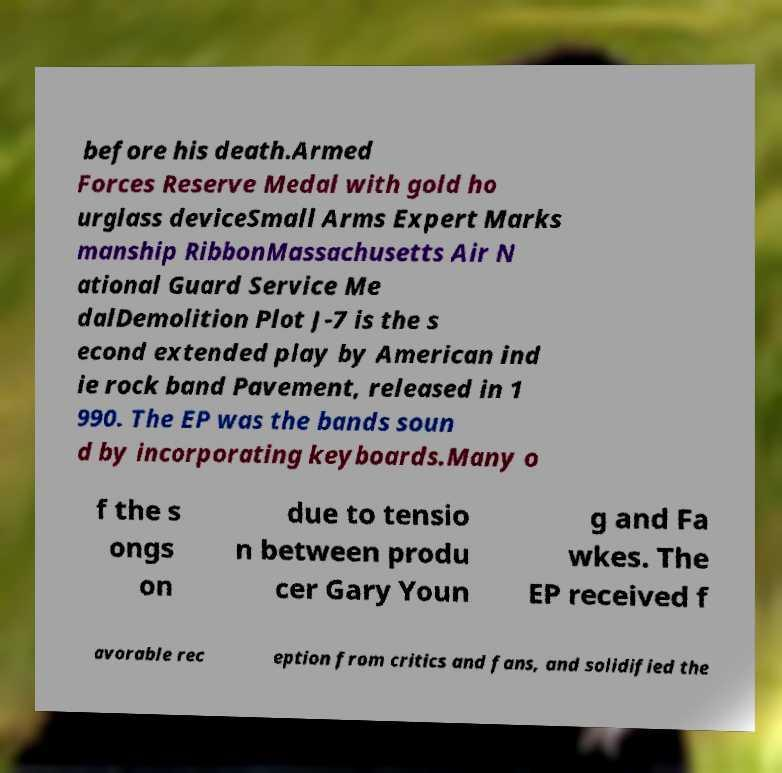I need the written content from this picture converted into text. Can you do that? before his death.Armed Forces Reserve Medal with gold ho urglass deviceSmall Arms Expert Marks manship RibbonMassachusetts Air N ational Guard Service Me dalDemolition Plot J-7 is the s econd extended play by American ind ie rock band Pavement, released in 1 990. The EP was the bands soun d by incorporating keyboards.Many o f the s ongs on due to tensio n between produ cer Gary Youn g and Fa wkes. The EP received f avorable rec eption from critics and fans, and solidified the 